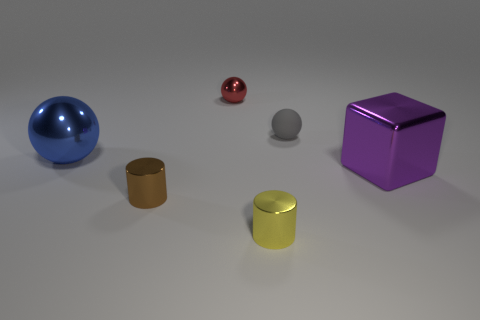Add 2 small gray balls. How many objects exist? 8 Subtract all cubes. How many objects are left? 5 Subtract all small red metal objects. Subtract all tiny red metallic objects. How many objects are left? 4 Add 1 big metal cubes. How many big metal cubes are left? 2 Add 4 large blue matte things. How many large blue matte things exist? 4 Subtract 0 yellow spheres. How many objects are left? 6 